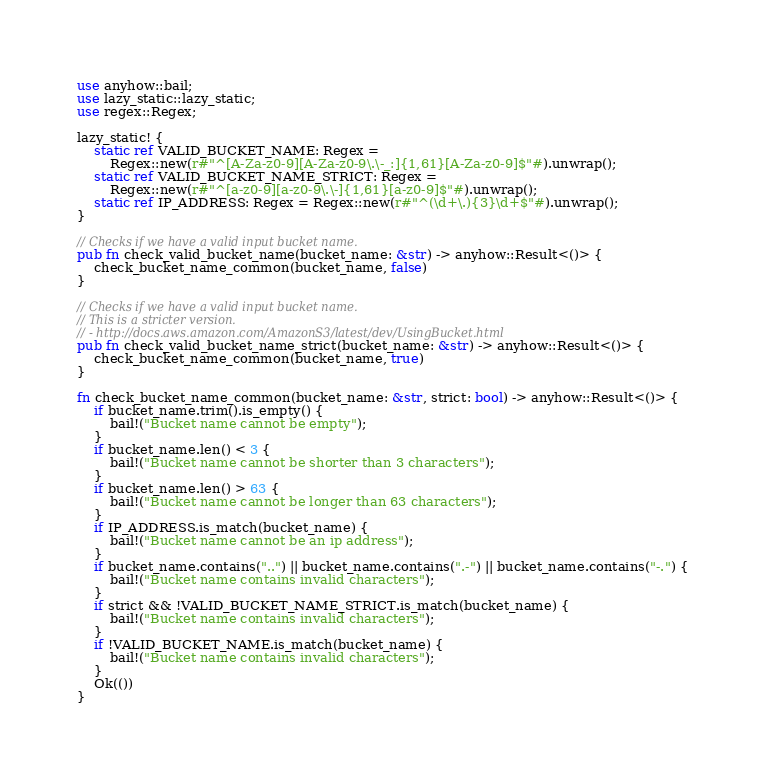<code> <loc_0><loc_0><loc_500><loc_500><_Rust_>use anyhow::bail;
use lazy_static::lazy_static;
use regex::Regex;

lazy_static! {
    static ref VALID_BUCKET_NAME: Regex =
        Regex::new(r#"^[A-Za-z0-9][A-Za-z0-9\.\-_:]{1,61}[A-Za-z0-9]$"#).unwrap();
    static ref VALID_BUCKET_NAME_STRICT: Regex =
        Regex::new(r#"^[a-z0-9][a-z0-9\.\-]{1,61}[a-z0-9]$"#).unwrap();
    static ref IP_ADDRESS: Regex = Regex::new(r#"^(\d+\.){3}\d+$"#).unwrap();
}

// Checks if we have a valid input bucket name.
pub fn check_valid_bucket_name(bucket_name: &str) -> anyhow::Result<()> {
    check_bucket_name_common(bucket_name, false)
}

// Checks if we have a valid input bucket name.
// This is a stricter version.
// - http://docs.aws.amazon.com/AmazonS3/latest/dev/UsingBucket.html
pub fn check_valid_bucket_name_strict(bucket_name: &str) -> anyhow::Result<()> {
    check_bucket_name_common(bucket_name, true)
}

fn check_bucket_name_common(bucket_name: &str, strict: bool) -> anyhow::Result<()> {
    if bucket_name.trim().is_empty() {
        bail!("Bucket name cannot be empty");
    }
    if bucket_name.len() < 3 {
        bail!("Bucket name cannot be shorter than 3 characters");
    }
    if bucket_name.len() > 63 {
        bail!("Bucket name cannot be longer than 63 characters");
    }
    if IP_ADDRESS.is_match(bucket_name) {
        bail!("Bucket name cannot be an ip address");
    }
    if bucket_name.contains("..") || bucket_name.contains(".-") || bucket_name.contains("-.") {
        bail!("Bucket name contains invalid characters");
    }
    if strict && !VALID_BUCKET_NAME_STRICT.is_match(bucket_name) {
        bail!("Bucket name contains invalid characters");
    }
    if !VALID_BUCKET_NAME.is_match(bucket_name) {
        bail!("Bucket name contains invalid characters");
    }
    Ok(())
}
</code> 